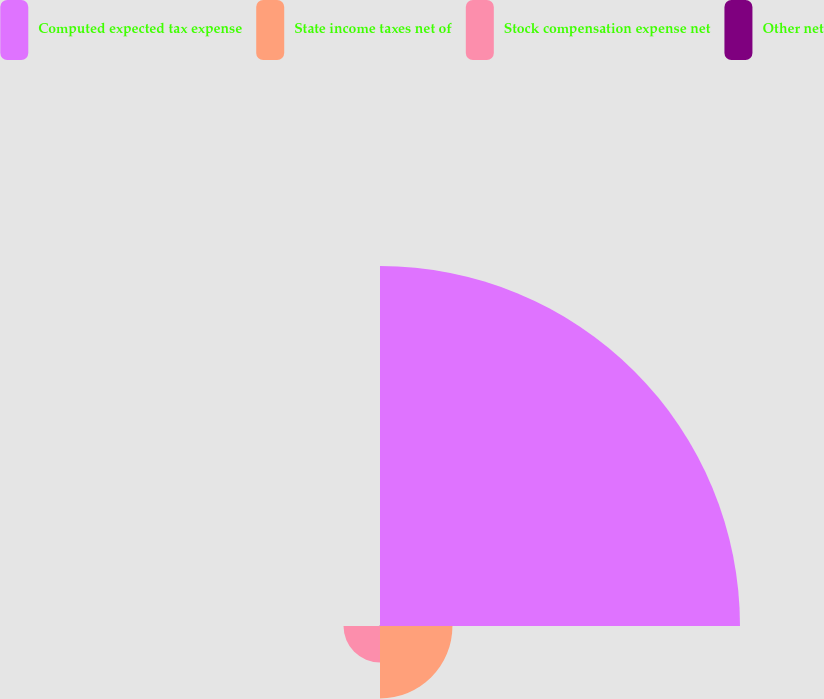Convert chart. <chart><loc_0><loc_0><loc_500><loc_500><pie_chart><fcel>Computed expected tax expense<fcel>State income taxes net of<fcel>Stock compensation expense net<fcel>Other net<nl><fcel>76.68%<fcel>15.43%<fcel>7.77%<fcel>0.12%<nl></chart> 